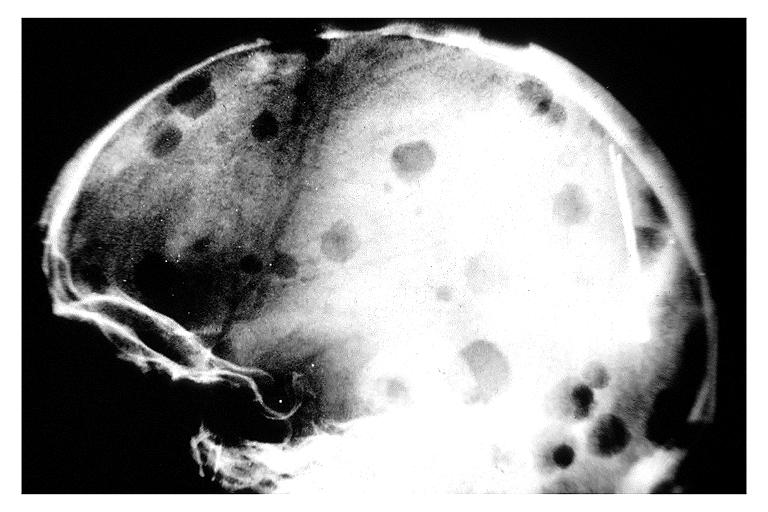where is this?
Answer the question using a single word or phrase. Oral 